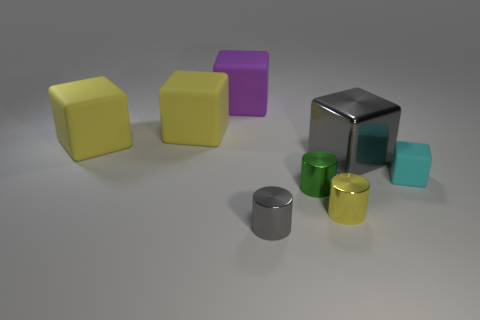Subtract all gray cubes. How many cubes are left? 4 Subtract all red spheres. How many yellow blocks are left? 2 Subtract 1 blocks. How many blocks are left? 4 Add 1 cyan things. How many objects exist? 9 Subtract all yellow cubes. How many cubes are left? 3 Subtract all cubes. How many objects are left? 3 Subtract all red cubes. Subtract all blue cylinders. How many cubes are left? 5 Add 4 big brown matte balls. How many big brown matte balls exist? 4 Subtract 1 gray blocks. How many objects are left? 7 Subtract all big purple balls. Subtract all small blocks. How many objects are left? 7 